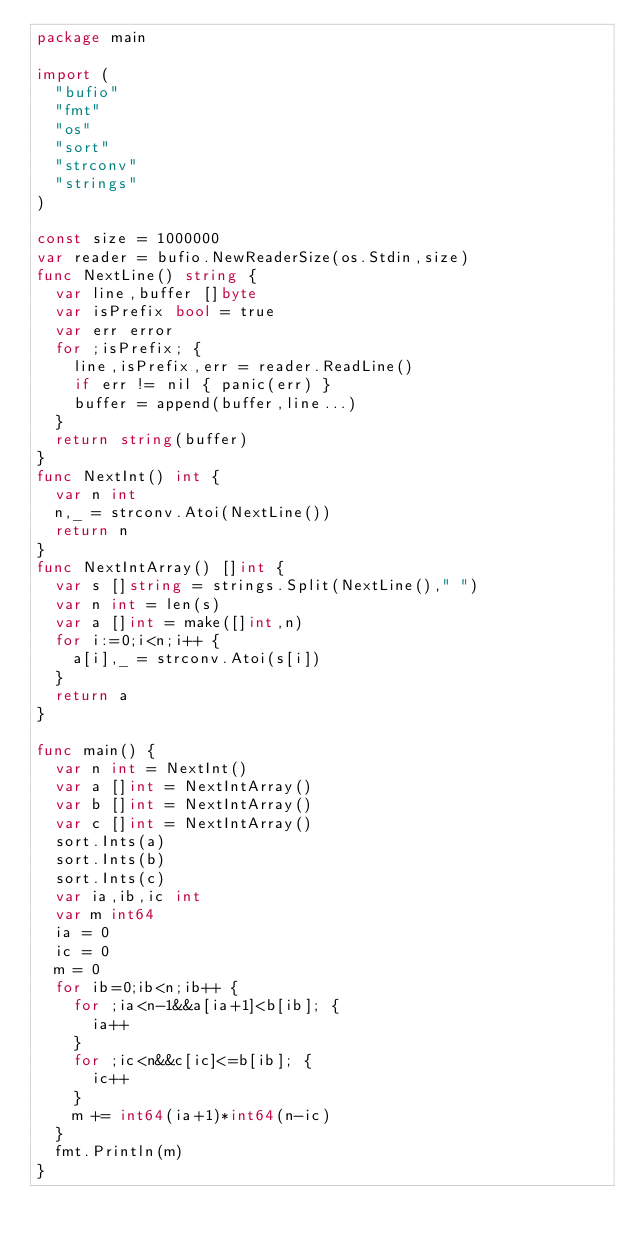<code> <loc_0><loc_0><loc_500><loc_500><_Go_>package main

import (
  "bufio"
  "fmt"
  "os"
  "sort"
  "strconv"
  "strings"
)

const size = 1000000
var reader = bufio.NewReaderSize(os.Stdin,size)
func NextLine() string {
  var line,buffer []byte
  var isPrefix bool = true
  var err error
  for ;isPrefix; {
    line,isPrefix,err = reader.ReadLine()
    if err != nil { panic(err) }
    buffer = append(buffer,line...)
  }
  return string(buffer)
}
func NextInt() int {
  var n int
  n,_ = strconv.Atoi(NextLine())
  return n
}
func NextIntArray() []int {
  var s []string = strings.Split(NextLine()," ")
  var n int = len(s)
  var a []int = make([]int,n)
  for i:=0;i<n;i++ {
    a[i],_ = strconv.Atoi(s[i])
  }
  return a
}

func main() {
  var n int = NextInt()
  var a []int = NextIntArray()
  var b []int = NextIntArray()
  var c []int = NextIntArray()
  sort.Ints(a)
  sort.Ints(b)
  sort.Ints(c)
  var ia,ib,ic int
  var m int64
  ia = 0
  ic = 0
  m = 0
  for ib=0;ib<n;ib++ {
    for ;ia<n-1&&a[ia+1]<b[ib]; {
      ia++
    }
    for ;ic<n&&c[ic]<=b[ib]; {
      ic++
    }
    m += int64(ia+1)*int64(n-ic)
  }
  fmt.Println(m)
}</code> 